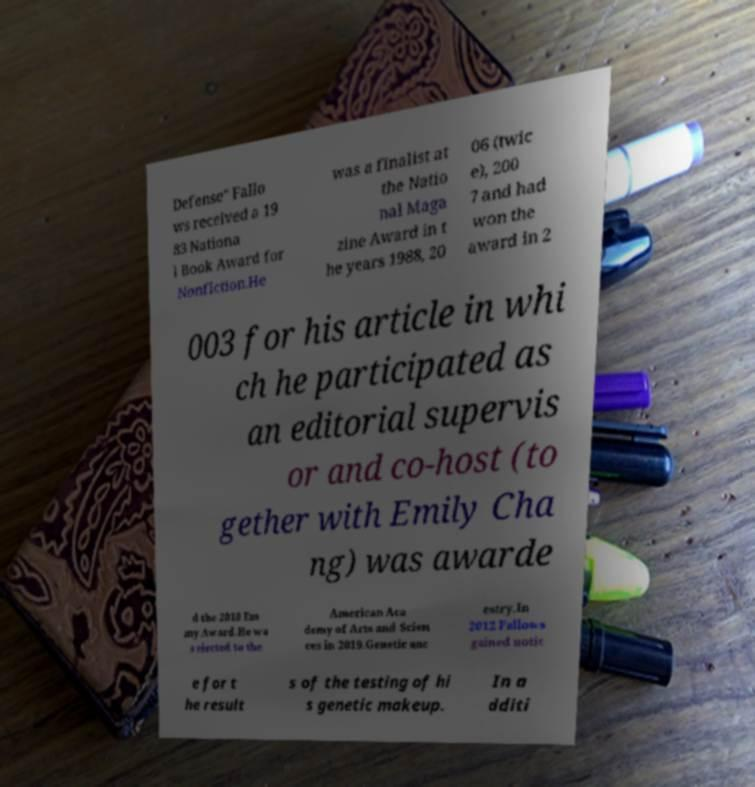Could you extract and type out the text from this image? Defense" Fallo ws received a 19 83 Nationa l Book Award for Nonfiction.He was a finalist at the Natio nal Maga zine Award in t he years 1988, 20 06 (twic e), 200 7 and had won the award in 2 003 for his article in whi ch he participated as an editorial supervis or and co-host (to gether with Emily Cha ng) was awarde d the 2010 Em my Award.He wa s elected to the American Aca demy of Arts and Scien ces in 2019.Genetic anc estry.In 2012 Fallows gained notic e for t he result s of the testing of hi s genetic makeup. In a dditi 